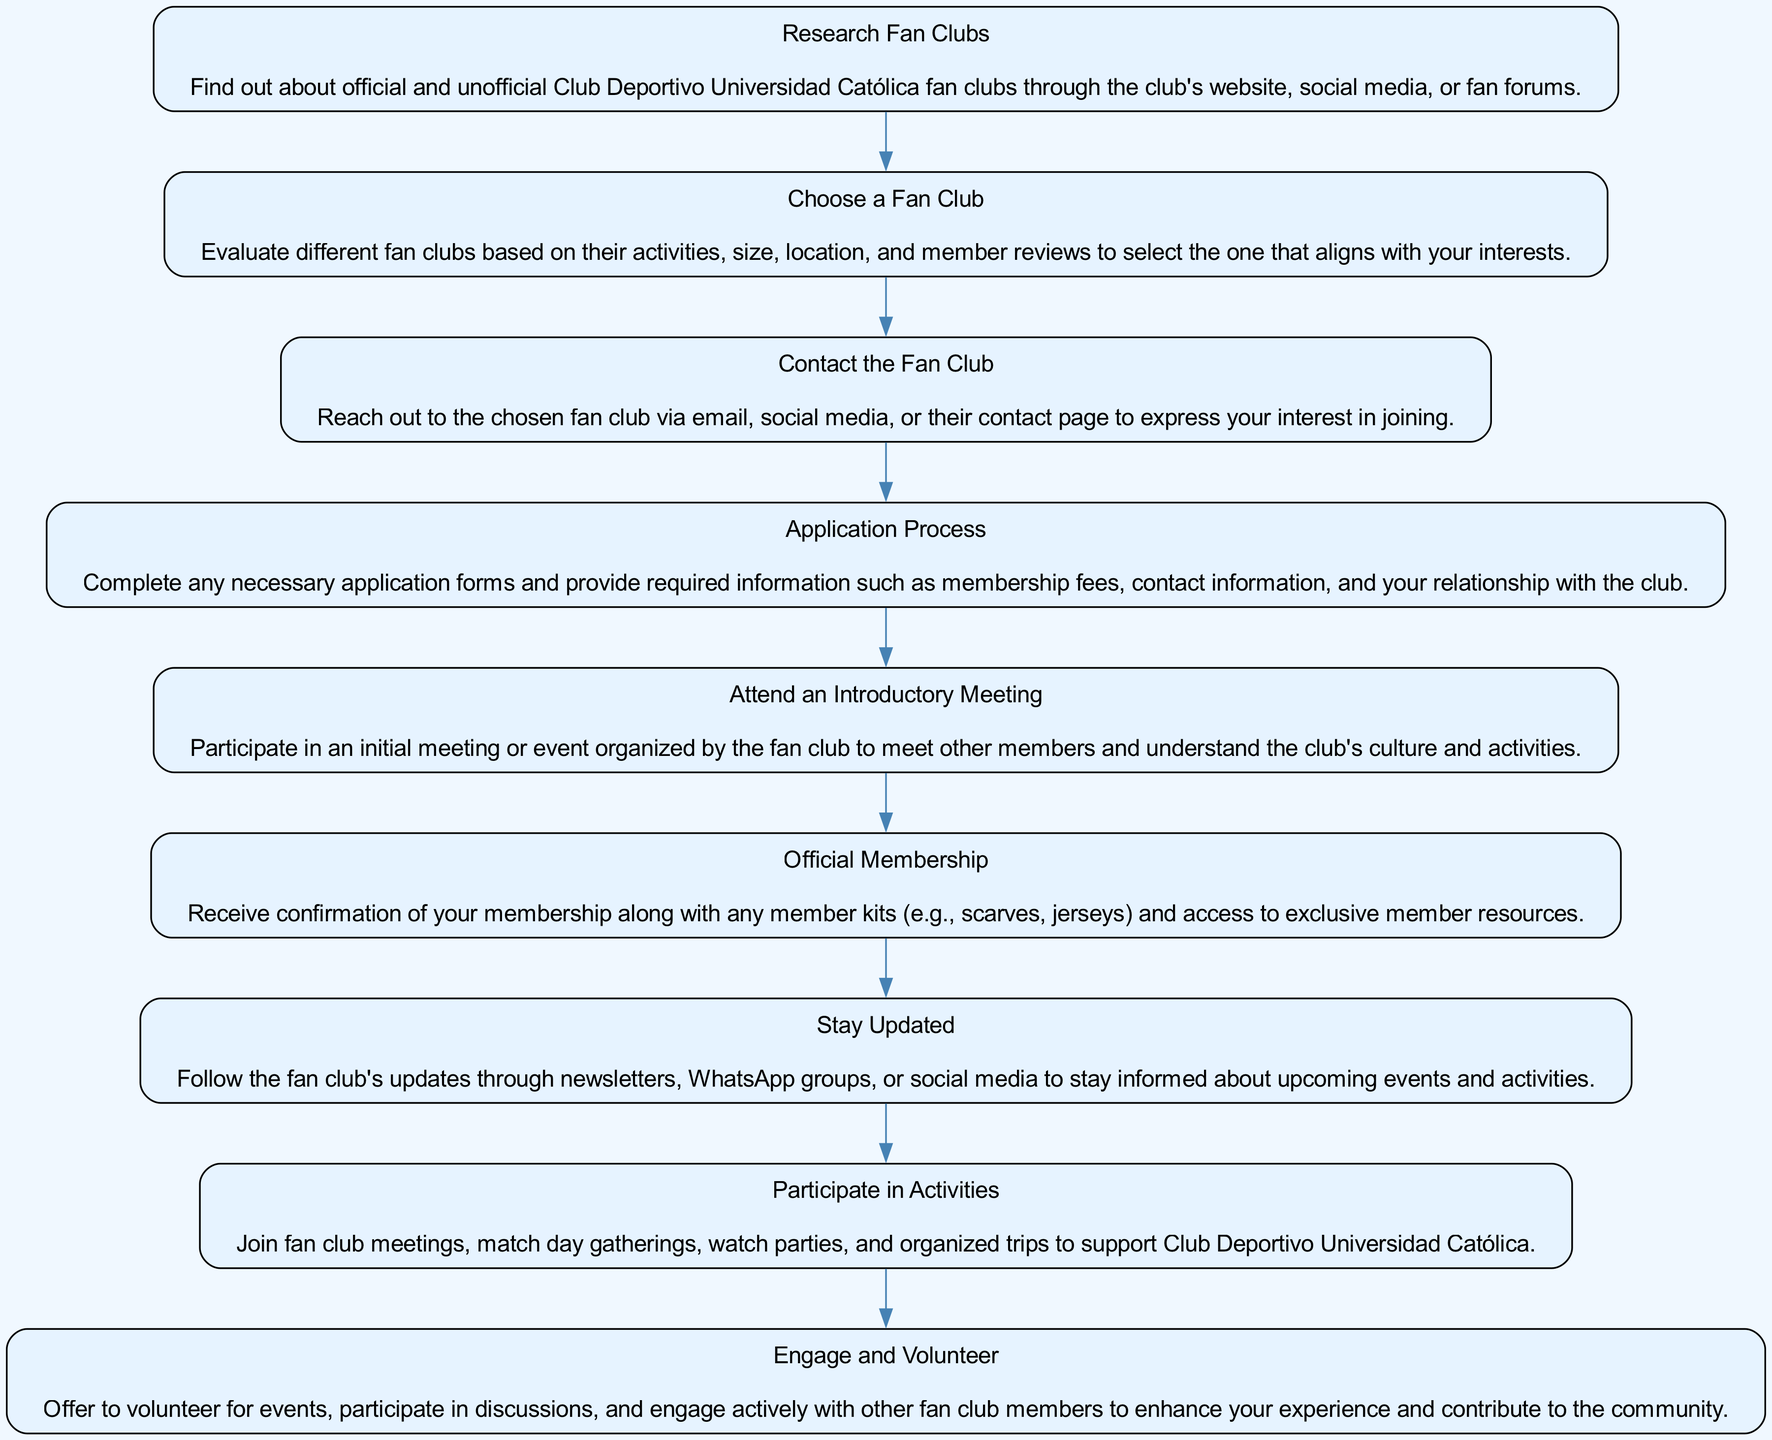What is the first step to join a fan club? The diagram clearly indicates that the first step in the process is "Research Fan Clubs". It is the initial action that a prospective member must take before proceeding with joining any fan club.
Answer: Research Fan Clubs How many steps are there in the diagram? By counting each distinct step presented in the flow chart, you find there are nine steps in total. This requires careful examination of each node to ascertain the complete list of actions to join and participate in a fan club.
Answer: Nine What is the last action that one should take? The final step outlined in the diagram is "Engage and Volunteer." This indicates that after becoming a member, an individual should actively participate in the fan club's activities.
Answer: Engage and Volunteer Which step follows "Attend an Introductory Meeting"? According to the flow sequence depicted, the step that directly follows "Attend an Introductory Meeting" is "Official Membership." This illustrates the progression from attending an introductory event to receiving formal confirmation of membership.
Answer: Official Membership What is the purpose of the "Stay Updated" step? The purpose of the "Stay Updated" step is to ensure that members are informed about upcoming events and activities through various channels like newsletters and social media. This emphasizes the importance of ongoing communication within the fan club.
Answer: Stay informed about events What action should you take after "Contact the Fan Club"? After "Contact the Fan Club," the next step is the "Application Process," which requires completing the necessary forms and providing information related to membership. This sequential action highlights the transition from initial contact to formal application.
Answer: Application Process What is the focus of the "Participate in Activities" step? The "Participate in Activities" step focuses on actively joining meetings, gatherings, and organized events that support Club Deportivo Universidad Católica, illustrating the member's involvement in the fan club's life.
Answer: Active participation in club events What is required during the "Application Process"? The "Application Process" requires several elements, including completing application forms, payment of membership fees, and providing personal contact information, illustrating the formal requirements for becoming a member.
Answer: Membership fees and contact information Which step emphasizes initial communication with the fan club? The step that emphasizes initial communication is "Contact the Fan Club," which highlights the importance of reaching out and expressing interest as the first direct engagement with the fan club.
Answer: Contact the Fan Club 